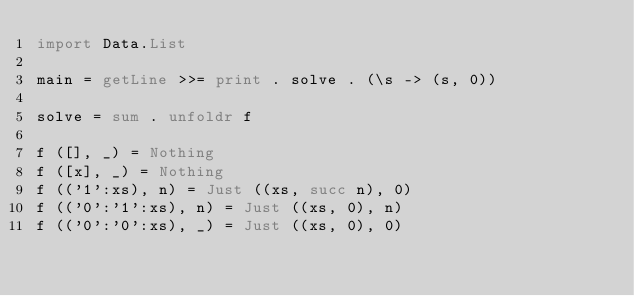<code> <loc_0><loc_0><loc_500><loc_500><_Haskell_>import Data.List

main = getLine >>= print . solve . (\s -> (s, 0))
 
solve = sum . unfoldr f 
 
f ([], _) = Nothing
f ([x], _) = Nothing
f (('1':xs), n) = Just ((xs, succ n), 0)
f (('0':'1':xs), n) = Just ((xs, 0), n)
f (('0':'0':xs), _) = Just ((xs, 0), 0)
 </code> 